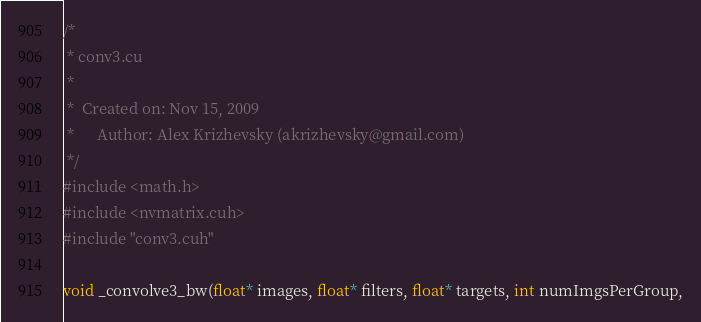<code> <loc_0><loc_0><loc_500><loc_500><_Cuda_>/*
 * conv3.cu
 *
 *  Created on: Nov 15, 2009
 *      Author: Alex Krizhevsky (akrizhevsky@gmail.com)
 */
#include <math.h>
#include <nvmatrix.cuh>
#include "conv3.cuh"

void _convolve3_bw(float* images, float* filters, float* targets, int numImgsPerGroup,</code> 